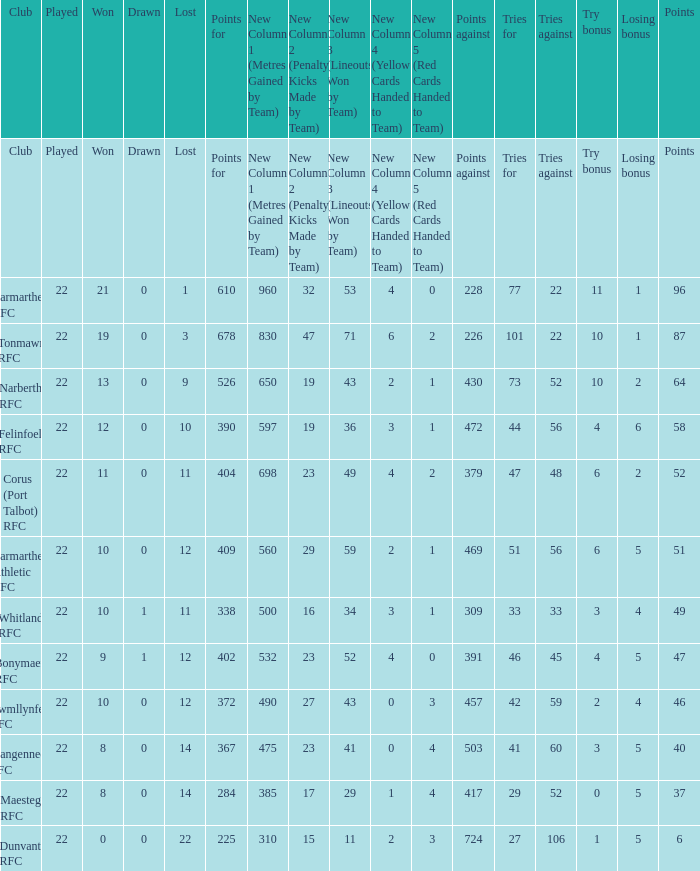Name the losing bonus for 27 5.0. 